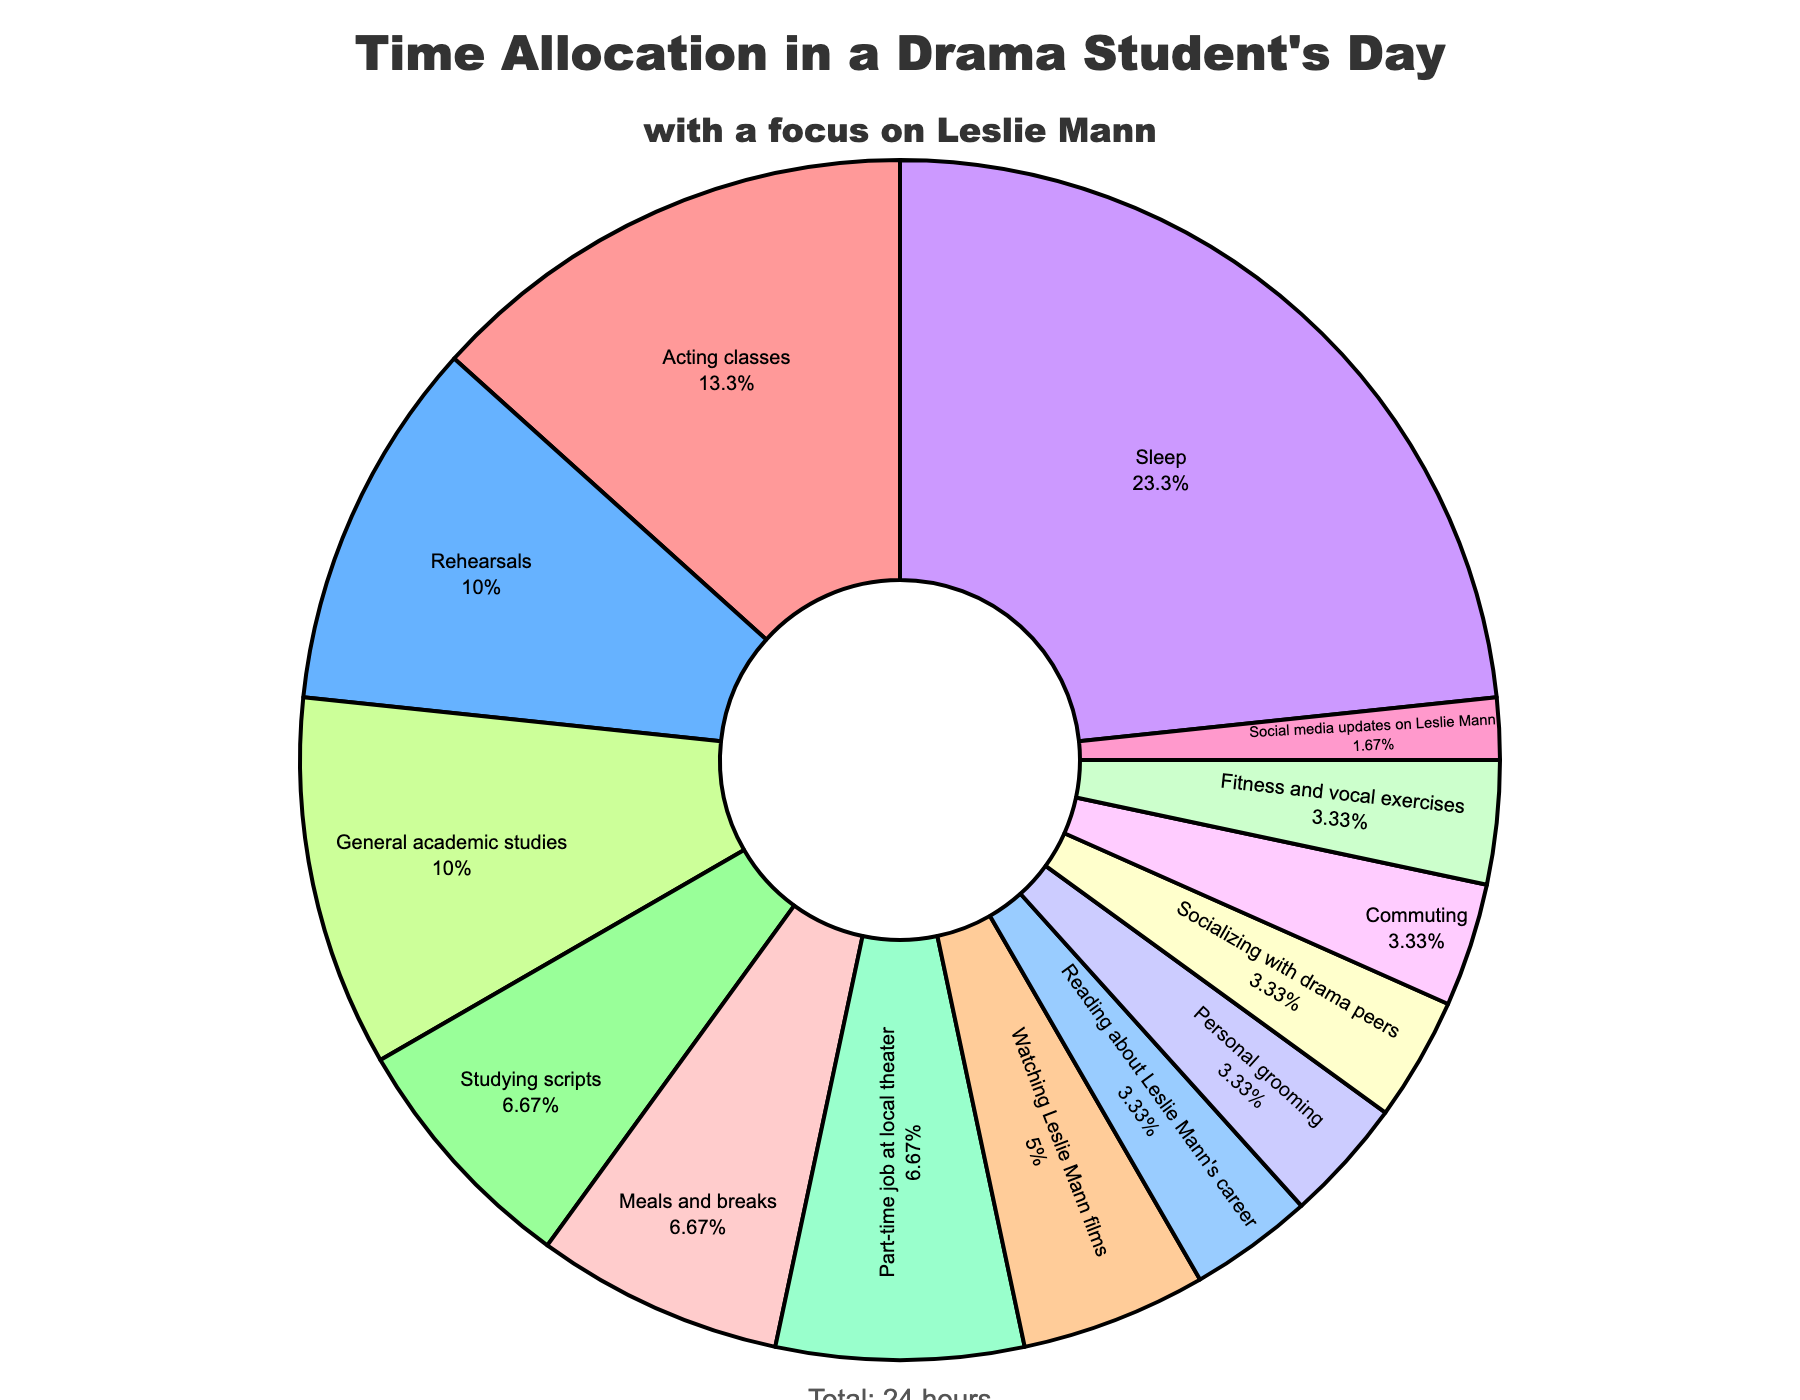In which activity does the drama student spend the most time? The activity with the largest slice of the pie chart is sleep, which indicates the highest time allocation.
Answer: Sleep How much total time is spent on activities related to Leslie Mann? Adding the hours spent on watching Leslie Mann films (1.5), social media updates on Leslie Mann (0.5), and reading about Leslie Mann's career (1) results in a total of 1.5 + 0.5 + 1 = 3 hours.
Answer: 3 hours Which two activities have the smallest allocations of time? The activities with the smallest slices on the pie chart are social media updates on Leslie Mann (0.5 hours) and personal grooming (1 hour).
Answer: Social media updates on Leslie Mann, Personal grooming Is more time spent on rehearsals or commuting? By how much? The pie chart shows that rehearsals (3 hours) have a larger slice compared to commuting (1 hour). The difference is 3 - 1 = 2 hours.
Answer: Rehearsals by 2 hours What is the combined time spent on acting classes and general academic studies? The pie chart shows 4 hours for acting classes and 3 hours for general academic studies. The combined time is 4 + 3 = 7 hours.
Answer: 7 hours What percentage of the day is spent on eating meals and taking breaks? The pie chart segment for meals and breaks is specified inside the segment.
Answer: 8.33% Which activity has a slightly larger time allocation: fitness and vocal exercises or personal grooming? The pie chart indicates that fitness and vocal exercises are allocated 1 hour and personal grooming is also allocated 1 hour, thus they are equal.
Answer: Equal How much more time is spent on rehearsals than on a part-time job at the local theater? The pie chart shows 3 hours for rehearsals and 2 hours for the part-time job at the local theater. The difference is 3 - 2 = 1 hour.
Answer: 1 hour Which activity represents exactly one hour of the student's day? The pie chart indicates that personal grooming, fitness and vocal exercises, and commuting each represent exactly 1 hour of the student's day.
Answer: Personal grooming, fitness and vocal exercises, commuting By what fraction of the total time is sleep more than rehearsals? Sleep is 7 hours and rehearsals are 3 hours. The difference is 7 - 3 = 4 hours. The total time is 24 hours. So, the fraction is 4/24 or 1/6.
Answer: 1/6 